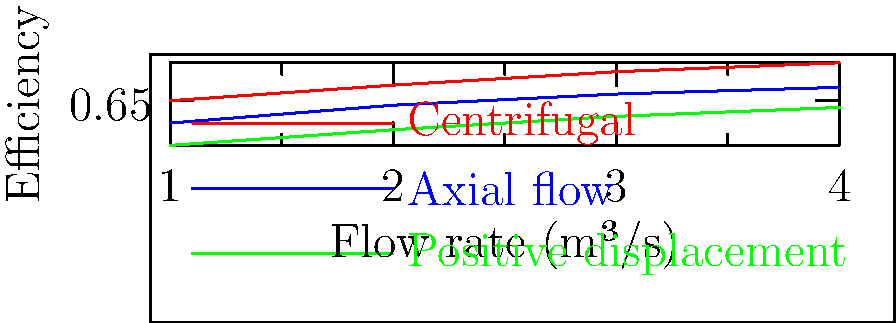Based on the efficiency curves shown in the graph for different types of water pumps, which pump design would be most suitable for a high-flow rate application in a water conservation project? Explain your reasoning considering the efficiency at higher flow rates. To determine the most suitable pump design for a high-flow rate application, we need to analyze the efficiency curves for each pump type at higher flow rates:

1. Centrifugal pump (red line):
   - Starts at the highest efficiency at low flow rates
   - Maintains the highest efficiency throughout the range
   - Efficiency increases steadily with flow rate
   - At 4 m³/s, it reaches an efficiency of about 0.82 or 82%

2. Axial flow pump (blue line):
   - Starts at a lower efficiency than the centrifugal pump
   - Efficiency increases with flow rate but remains lower than centrifugal
   - At 4 m³/s, it reaches an efficiency of about 0.71 or 71%

3. Positive displacement pump (green line):
   - Starts at the lowest efficiency
   - Efficiency increases with flow rate but remains the lowest of the three
   - At 4 m³/s, it reaches an efficiency of about 0.62 or 62%

For high-flow rate applications, we want a pump that maintains high efficiency at higher flow rates. The centrifugal pump clearly outperforms the other two designs in this aspect, showing the highest efficiency across all flow rates and continuing to improve as the flow rate increases.

Therefore, the centrifugal pump design would be the most suitable for a high-flow rate application in a water conservation project. It would provide the best energy efficiency, which is crucial for conservation efforts, especially at the higher flow rates that might be required for larger-scale water management tasks.
Answer: Centrifugal pump, due to highest efficiency at high flow rates. 